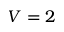Convert formula to latex. <formula><loc_0><loc_0><loc_500><loc_500>V = 2</formula> 